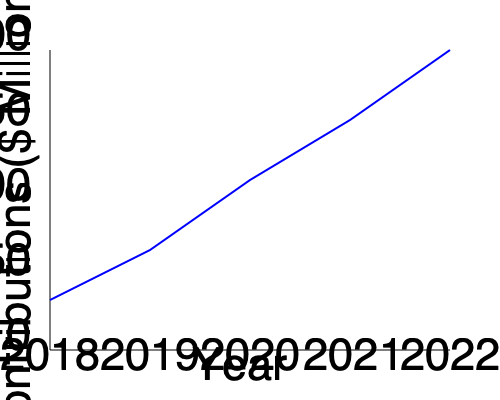Based on the line graph showing the growth of charitable contributions from 2018 to 2022, what was the approximate percentage increase in contributions between 2018 and 2022? To calculate the percentage increase in charitable contributions between 2018 and 2022:

1. Identify the contribution values:
   2018: approximately $50 million
   2022: approximately $200 million

2. Calculate the difference:
   $200 million - $50 million = $150 million increase

3. Use the percentage increase formula:
   Percentage increase = (Increase / Original Value) × 100
   = ($150 million / $50 million) × 100
   = 3 × 100
   = 300%

Therefore, the approximate percentage increase in charitable contributions between 2018 and 2022 was 300%.
Answer: 300% 